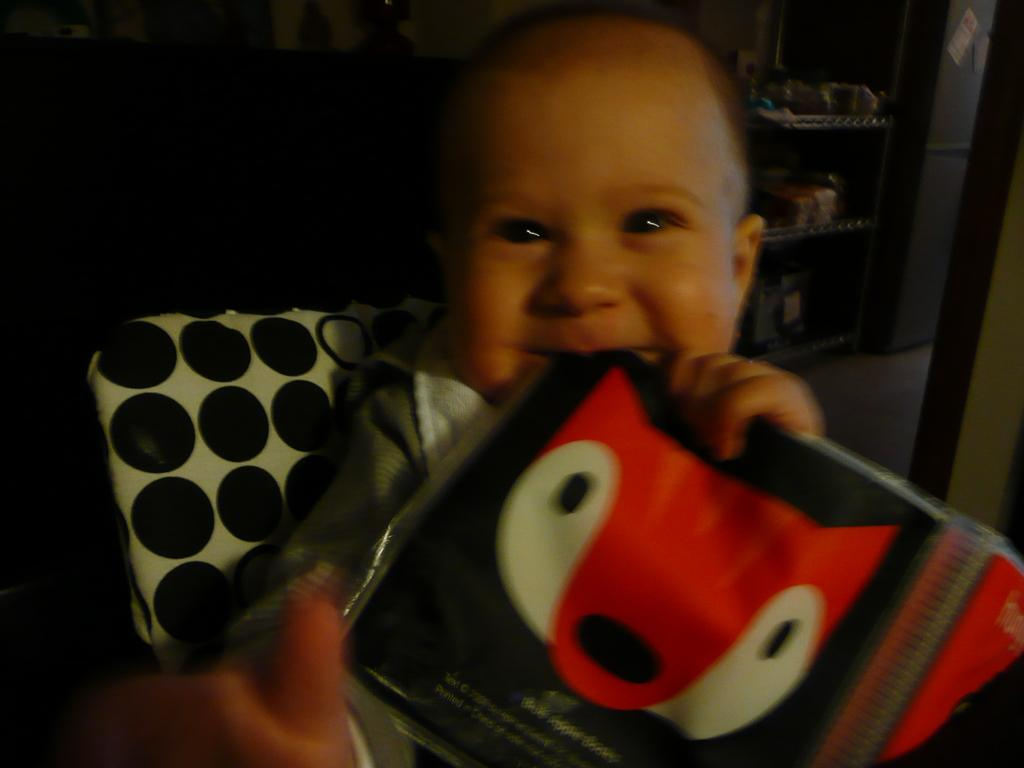What is the main subject of the image? The main subject of the image is a kid. What is the kid doing in the image? The kid is holding an object. What can be seen in the background of the image? There is a rack in the background of the image. What is placed on the rack? There are objects placed in the rack. What type of discussion is taking place between the kid and the crate in the image? There is no crate present in the image, and therefore no discussion can be observed. 